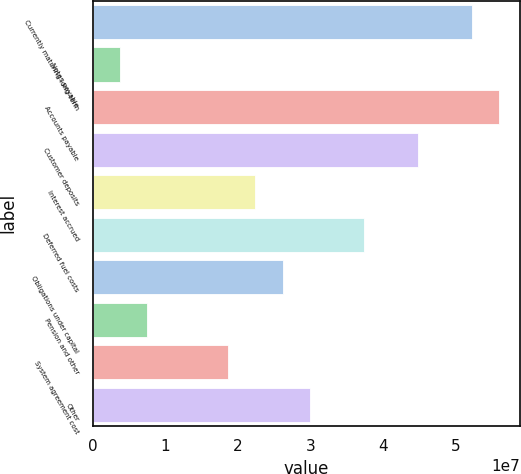Convert chart. <chart><loc_0><loc_0><loc_500><loc_500><bar_chart><fcel>Currently maturing long-term<fcel>Notes payable<fcel>Accounts payable<fcel>Customer deposits<fcel>Interest accrued<fcel>Deferred fuel costs<fcel>Obligations under capital<fcel>Pension and other<fcel>System agreement cost<fcel>Other<nl><fcel>5.23094e+07<fcel>3.73875e+06<fcel>5.60456e+07<fcel>4.4837e+07<fcel>2.24198e+07<fcel>3.73646e+07<fcel>2.6156e+07<fcel>7.47496e+06<fcel>1.86836e+07<fcel>2.98922e+07<nl></chart> 